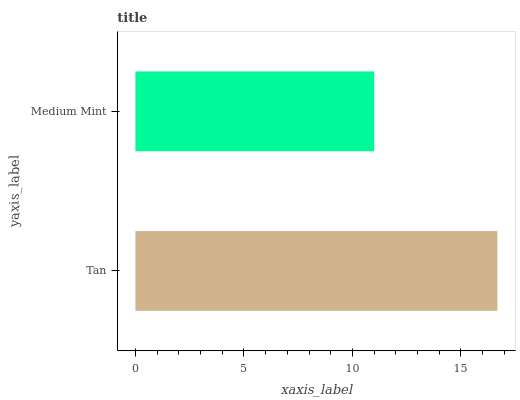Is Medium Mint the minimum?
Answer yes or no. Yes. Is Tan the maximum?
Answer yes or no. Yes. Is Medium Mint the maximum?
Answer yes or no. No. Is Tan greater than Medium Mint?
Answer yes or no. Yes. Is Medium Mint less than Tan?
Answer yes or no. Yes. Is Medium Mint greater than Tan?
Answer yes or no. No. Is Tan less than Medium Mint?
Answer yes or no. No. Is Tan the high median?
Answer yes or no. Yes. Is Medium Mint the low median?
Answer yes or no. Yes. Is Medium Mint the high median?
Answer yes or no. No. Is Tan the low median?
Answer yes or no. No. 